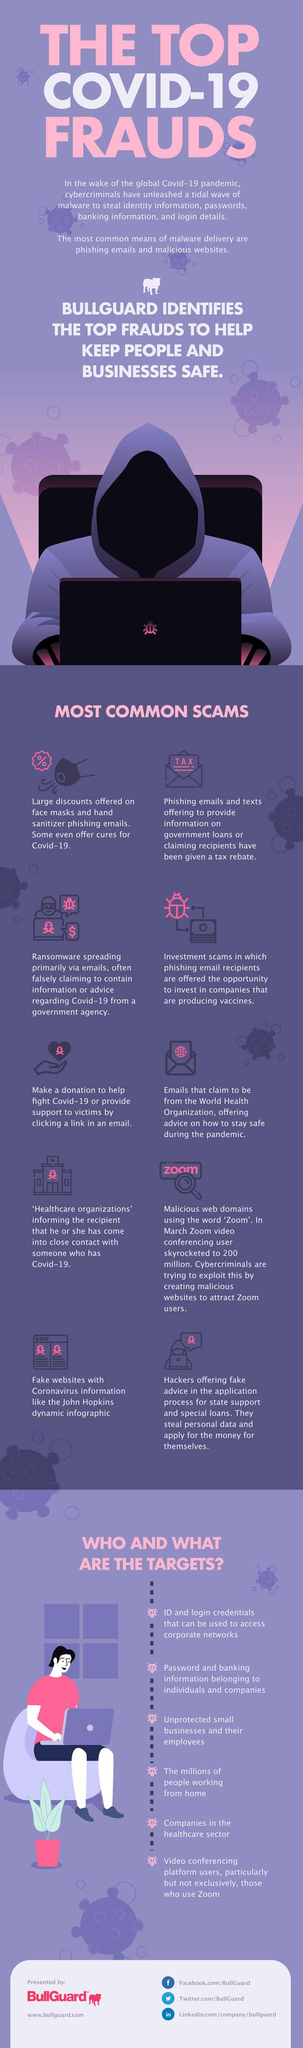Identify some key points in this picture. The infographic mentions 10 scams. 